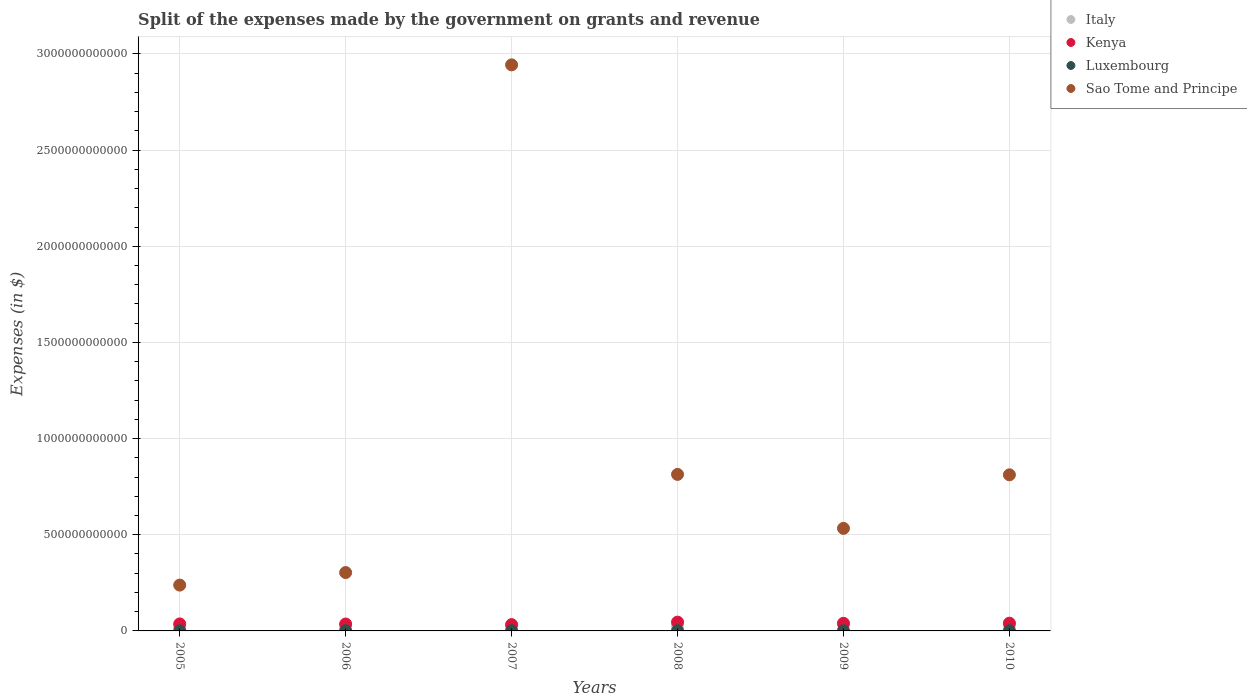How many different coloured dotlines are there?
Provide a succinct answer. 4. Is the number of dotlines equal to the number of legend labels?
Offer a terse response. Yes. What is the expenses made by the government on grants and revenue in Luxembourg in 2005?
Offer a terse response. 7.36e+08. Across all years, what is the maximum expenses made by the government on grants and revenue in Sao Tome and Principe?
Offer a very short reply. 2.94e+12. Across all years, what is the minimum expenses made by the government on grants and revenue in Luxembourg?
Your answer should be compact. 7.36e+08. In which year was the expenses made by the government on grants and revenue in Luxembourg maximum?
Offer a very short reply. 2008. In which year was the expenses made by the government on grants and revenue in Luxembourg minimum?
Make the answer very short. 2005. What is the total expenses made by the government on grants and revenue in Kenya in the graph?
Your response must be concise. 2.31e+11. What is the difference between the expenses made by the government on grants and revenue in Kenya in 2006 and that in 2008?
Give a very brief answer. -9.88e+09. What is the difference between the expenses made by the government on grants and revenue in Luxembourg in 2006 and the expenses made by the government on grants and revenue in Kenya in 2005?
Offer a terse response. -3.55e+1. What is the average expenses made by the government on grants and revenue in Kenya per year?
Give a very brief answer. 3.85e+1. In the year 2010, what is the difference between the expenses made by the government on grants and revenue in Kenya and expenses made by the government on grants and revenue in Luxembourg?
Offer a very short reply. 3.91e+1. What is the ratio of the expenses made by the government on grants and revenue in Italy in 2005 to that in 2010?
Keep it short and to the point. 0.76. Is the expenses made by the government on grants and revenue in Italy in 2006 less than that in 2010?
Provide a short and direct response. Yes. Is the difference between the expenses made by the government on grants and revenue in Kenya in 2006 and 2008 greater than the difference between the expenses made by the government on grants and revenue in Luxembourg in 2006 and 2008?
Your response must be concise. No. What is the difference between the highest and the second highest expenses made by the government on grants and revenue in Kenya?
Your answer should be very brief. 5.50e+09. What is the difference between the highest and the lowest expenses made by the government on grants and revenue in Kenya?
Your answer should be compact. 1.30e+1. In how many years, is the expenses made by the government on grants and revenue in Sao Tome and Principe greater than the average expenses made by the government on grants and revenue in Sao Tome and Principe taken over all years?
Your answer should be compact. 1. Is the expenses made by the government on grants and revenue in Sao Tome and Principe strictly greater than the expenses made by the government on grants and revenue in Kenya over the years?
Provide a short and direct response. Yes. Is the expenses made by the government on grants and revenue in Sao Tome and Principe strictly less than the expenses made by the government on grants and revenue in Italy over the years?
Make the answer very short. No. How many years are there in the graph?
Give a very brief answer. 6. What is the difference between two consecutive major ticks on the Y-axis?
Offer a terse response. 5.00e+11. Are the values on the major ticks of Y-axis written in scientific E-notation?
Provide a short and direct response. No. Does the graph contain any zero values?
Your answer should be very brief. No. How are the legend labels stacked?
Your answer should be very brief. Vertical. What is the title of the graph?
Make the answer very short. Split of the expenses made by the government on grants and revenue. Does "Brunei Darussalam" appear as one of the legend labels in the graph?
Your answer should be compact. No. What is the label or title of the X-axis?
Your response must be concise. Years. What is the label or title of the Y-axis?
Give a very brief answer. Expenses (in $). What is the Expenses (in $) of Italy in 2005?
Offer a very short reply. 2.16e+1. What is the Expenses (in $) of Kenya in 2005?
Keep it short and to the point. 3.64e+1. What is the Expenses (in $) of Luxembourg in 2005?
Provide a short and direct response. 7.36e+08. What is the Expenses (in $) in Sao Tome and Principe in 2005?
Ensure brevity in your answer.  2.38e+11. What is the Expenses (in $) in Italy in 2006?
Make the answer very short. 2.53e+1. What is the Expenses (in $) of Kenya in 2006?
Give a very brief answer. 3.59e+1. What is the Expenses (in $) in Luxembourg in 2006?
Make the answer very short. 9.05e+08. What is the Expenses (in $) of Sao Tome and Principe in 2006?
Provide a short and direct response. 3.04e+11. What is the Expenses (in $) of Italy in 2007?
Provide a succinct answer. 2.34e+1. What is the Expenses (in $) of Kenya in 2007?
Offer a terse response. 3.28e+1. What is the Expenses (in $) of Luxembourg in 2007?
Provide a succinct answer. 1.03e+09. What is the Expenses (in $) in Sao Tome and Principe in 2007?
Make the answer very short. 2.94e+12. What is the Expenses (in $) in Italy in 2008?
Your response must be concise. 2.44e+1. What is the Expenses (in $) of Kenya in 2008?
Provide a succinct answer. 4.58e+1. What is the Expenses (in $) in Luxembourg in 2008?
Provide a short and direct response. 1.19e+09. What is the Expenses (in $) of Sao Tome and Principe in 2008?
Provide a succinct answer. 8.14e+11. What is the Expenses (in $) in Italy in 2009?
Provide a succinct answer. 3.13e+1. What is the Expenses (in $) of Kenya in 2009?
Offer a terse response. 3.98e+1. What is the Expenses (in $) of Luxembourg in 2009?
Your answer should be very brief. 1.07e+09. What is the Expenses (in $) of Sao Tome and Principe in 2009?
Ensure brevity in your answer.  5.33e+11. What is the Expenses (in $) in Italy in 2010?
Your answer should be very brief. 2.84e+1. What is the Expenses (in $) of Kenya in 2010?
Provide a short and direct response. 4.03e+1. What is the Expenses (in $) of Luxembourg in 2010?
Offer a terse response. 1.15e+09. What is the Expenses (in $) in Sao Tome and Principe in 2010?
Your response must be concise. 8.12e+11. Across all years, what is the maximum Expenses (in $) in Italy?
Provide a succinct answer. 3.13e+1. Across all years, what is the maximum Expenses (in $) in Kenya?
Ensure brevity in your answer.  4.58e+1. Across all years, what is the maximum Expenses (in $) in Luxembourg?
Give a very brief answer. 1.19e+09. Across all years, what is the maximum Expenses (in $) of Sao Tome and Principe?
Make the answer very short. 2.94e+12. Across all years, what is the minimum Expenses (in $) of Italy?
Provide a short and direct response. 2.16e+1. Across all years, what is the minimum Expenses (in $) of Kenya?
Your answer should be very brief. 3.28e+1. Across all years, what is the minimum Expenses (in $) in Luxembourg?
Your response must be concise. 7.36e+08. Across all years, what is the minimum Expenses (in $) in Sao Tome and Principe?
Ensure brevity in your answer.  2.38e+11. What is the total Expenses (in $) in Italy in the graph?
Ensure brevity in your answer.  1.54e+11. What is the total Expenses (in $) in Kenya in the graph?
Your response must be concise. 2.31e+11. What is the total Expenses (in $) in Luxembourg in the graph?
Your answer should be very brief. 6.08e+09. What is the total Expenses (in $) of Sao Tome and Principe in the graph?
Offer a terse response. 5.64e+12. What is the difference between the Expenses (in $) in Italy in 2005 and that in 2006?
Your answer should be compact. -3.68e+09. What is the difference between the Expenses (in $) of Kenya in 2005 and that in 2006?
Provide a short and direct response. 5.04e+08. What is the difference between the Expenses (in $) in Luxembourg in 2005 and that in 2006?
Provide a succinct answer. -1.69e+08. What is the difference between the Expenses (in $) in Sao Tome and Principe in 2005 and that in 2006?
Your answer should be compact. -6.52e+1. What is the difference between the Expenses (in $) of Italy in 2005 and that in 2007?
Offer a very short reply. -1.71e+09. What is the difference between the Expenses (in $) of Kenya in 2005 and that in 2007?
Provide a short and direct response. 3.58e+09. What is the difference between the Expenses (in $) of Luxembourg in 2005 and that in 2007?
Your response must be concise. -2.95e+08. What is the difference between the Expenses (in $) of Sao Tome and Principe in 2005 and that in 2007?
Ensure brevity in your answer.  -2.71e+12. What is the difference between the Expenses (in $) in Italy in 2005 and that in 2008?
Give a very brief answer. -2.72e+09. What is the difference between the Expenses (in $) of Kenya in 2005 and that in 2008?
Your answer should be very brief. -9.38e+09. What is the difference between the Expenses (in $) of Luxembourg in 2005 and that in 2008?
Make the answer very short. -4.51e+08. What is the difference between the Expenses (in $) in Sao Tome and Principe in 2005 and that in 2008?
Give a very brief answer. -5.76e+11. What is the difference between the Expenses (in $) of Italy in 2005 and that in 2009?
Give a very brief answer. -9.61e+09. What is the difference between the Expenses (in $) in Kenya in 2005 and that in 2009?
Provide a short and direct response. -3.35e+09. What is the difference between the Expenses (in $) of Luxembourg in 2005 and that in 2009?
Ensure brevity in your answer.  -3.34e+08. What is the difference between the Expenses (in $) of Sao Tome and Principe in 2005 and that in 2009?
Give a very brief answer. -2.95e+11. What is the difference between the Expenses (in $) in Italy in 2005 and that in 2010?
Make the answer very short. -6.76e+09. What is the difference between the Expenses (in $) of Kenya in 2005 and that in 2010?
Your response must be concise. -3.87e+09. What is the difference between the Expenses (in $) in Luxembourg in 2005 and that in 2010?
Keep it short and to the point. -4.15e+08. What is the difference between the Expenses (in $) in Sao Tome and Principe in 2005 and that in 2010?
Your answer should be compact. -5.73e+11. What is the difference between the Expenses (in $) in Italy in 2006 and that in 2007?
Your answer should be compact. 1.98e+09. What is the difference between the Expenses (in $) in Kenya in 2006 and that in 2007?
Your response must be concise. 3.07e+09. What is the difference between the Expenses (in $) in Luxembourg in 2006 and that in 2007?
Provide a succinct answer. -1.26e+08. What is the difference between the Expenses (in $) of Sao Tome and Principe in 2006 and that in 2007?
Ensure brevity in your answer.  -2.64e+12. What is the difference between the Expenses (in $) of Italy in 2006 and that in 2008?
Offer a terse response. 9.65e+08. What is the difference between the Expenses (in $) in Kenya in 2006 and that in 2008?
Provide a succinct answer. -9.88e+09. What is the difference between the Expenses (in $) of Luxembourg in 2006 and that in 2008?
Ensure brevity in your answer.  -2.82e+08. What is the difference between the Expenses (in $) of Sao Tome and Principe in 2006 and that in 2008?
Offer a terse response. -5.10e+11. What is the difference between the Expenses (in $) of Italy in 2006 and that in 2009?
Give a very brief answer. -5.92e+09. What is the difference between the Expenses (in $) of Kenya in 2006 and that in 2009?
Offer a very short reply. -3.86e+09. What is the difference between the Expenses (in $) of Luxembourg in 2006 and that in 2009?
Keep it short and to the point. -1.65e+08. What is the difference between the Expenses (in $) in Sao Tome and Principe in 2006 and that in 2009?
Keep it short and to the point. -2.30e+11. What is the difference between the Expenses (in $) in Italy in 2006 and that in 2010?
Offer a very short reply. -3.08e+09. What is the difference between the Expenses (in $) of Kenya in 2006 and that in 2010?
Give a very brief answer. -4.38e+09. What is the difference between the Expenses (in $) of Luxembourg in 2006 and that in 2010?
Your response must be concise. -2.45e+08. What is the difference between the Expenses (in $) of Sao Tome and Principe in 2006 and that in 2010?
Your answer should be very brief. -5.08e+11. What is the difference between the Expenses (in $) of Italy in 2007 and that in 2008?
Ensure brevity in your answer.  -1.01e+09. What is the difference between the Expenses (in $) of Kenya in 2007 and that in 2008?
Offer a very short reply. -1.30e+1. What is the difference between the Expenses (in $) in Luxembourg in 2007 and that in 2008?
Ensure brevity in your answer.  -1.56e+08. What is the difference between the Expenses (in $) in Sao Tome and Principe in 2007 and that in 2008?
Keep it short and to the point. 2.13e+12. What is the difference between the Expenses (in $) of Italy in 2007 and that in 2009?
Your answer should be compact. -7.90e+09. What is the difference between the Expenses (in $) in Kenya in 2007 and that in 2009?
Keep it short and to the point. -6.93e+09. What is the difference between the Expenses (in $) in Luxembourg in 2007 and that in 2009?
Offer a very short reply. -3.93e+07. What is the difference between the Expenses (in $) of Sao Tome and Principe in 2007 and that in 2009?
Keep it short and to the point. 2.41e+12. What is the difference between the Expenses (in $) in Italy in 2007 and that in 2010?
Provide a short and direct response. -5.05e+09. What is the difference between the Expenses (in $) in Kenya in 2007 and that in 2010?
Give a very brief answer. -7.45e+09. What is the difference between the Expenses (in $) of Luxembourg in 2007 and that in 2010?
Offer a terse response. -1.19e+08. What is the difference between the Expenses (in $) of Sao Tome and Principe in 2007 and that in 2010?
Your response must be concise. 2.13e+12. What is the difference between the Expenses (in $) in Italy in 2008 and that in 2009?
Offer a terse response. -6.89e+09. What is the difference between the Expenses (in $) in Kenya in 2008 and that in 2009?
Your answer should be very brief. 6.02e+09. What is the difference between the Expenses (in $) of Luxembourg in 2008 and that in 2009?
Make the answer very short. 1.17e+08. What is the difference between the Expenses (in $) in Sao Tome and Principe in 2008 and that in 2009?
Your answer should be compact. 2.81e+11. What is the difference between the Expenses (in $) in Italy in 2008 and that in 2010?
Provide a short and direct response. -4.04e+09. What is the difference between the Expenses (in $) in Kenya in 2008 and that in 2010?
Keep it short and to the point. 5.50e+09. What is the difference between the Expenses (in $) in Luxembourg in 2008 and that in 2010?
Your answer should be very brief. 3.67e+07. What is the difference between the Expenses (in $) of Sao Tome and Principe in 2008 and that in 2010?
Keep it short and to the point. 2.14e+09. What is the difference between the Expenses (in $) in Italy in 2009 and that in 2010?
Ensure brevity in your answer.  2.85e+09. What is the difference between the Expenses (in $) in Kenya in 2009 and that in 2010?
Your answer should be very brief. -5.18e+08. What is the difference between the Expenses (in $) in Luxembourg in 2009 and that in 2010?
Make the answer very short. -8.02e+07. What is the difference between the Expenses (in $) of Sao Tome and Principe in 2009 and that in 2010?
Offer a terse response. -2.78e+11. What is the difference between the Expenses (in $) in Italy in 2005 and the Expenses (in $) in Kenya in 2006?
Your answer should be compact. -1.43e+1. What is the difference between the Expenses (in $) of Italy in 2005 and the Expenses (in $) of Luxembourg in 2006?
Offer a terse response. 2.07e+1. What is the difference between the Expenses (in $) of Italy in 2005 and the Expenses (in $) of Sao Tome and Principe in 2006?
Provide a succinct answer. -2.82e+11. What is the difference between the Expenses (in $) of Kenya in 2005 and the Expenses (in $) of Luxembourg in 2006?
Your answer should be very brief. 3.55e+1. What is the difference between the Expenses (in $) of Kenya in 2005 and the Expenses (in $) of Sao Tome and Principe in 2006?
Your response must be concise. -2.67e+11. What is the difference between the Expenses (in $) of Luxembourg in 2005 and the Expenses (in $) of Sao Tome and Principe in 2006?
Provide a succinct answer. -3.03e+11. What is the difference between the Expenses (in $) of Italy in 2005 and the Expenses (in $) of Kenya in 2007?
Make the answer very short. -1.12e+1. What is the difference between the Expenses (in $) of Italy in 2005 and the Expenses (in $) of Luxembourg in 2007?
Ensure brevity in your answer.  2.06e+1. What is the difference between the Expenses (in $) in Italy in 2005 and the Expenses (in $) in Sao Tome and Principe in 2007?
Make the answer very short. -2.92e+12. What is the difference between the Expenses (in $) in Kenya in 2005 and the Expenses (in $) in Luxembourg in 2007?
Your answer should be very brief. 3.54e+1. What is the difference between the Expenses (in $) in Kenya in 2005 and the Expenses (in $) in Sao Tome and Principe in 2007?
Ensure brevity in your answer.  -2.91e+12. What is the difference between the Expenses (in $) of Luxembourg in 2005 and the Expenses (in $) of Sao Tome and Principe in 2007?
Provide a short and direct response. -2.94e+12. What is the difference between the Expenses (in $) in Italy in 2005 and the Expenses (in $) in Kenya in 2008?
Provide a succinct answer. -2.41e+1. What is the difference between the Expenses (in $) of Italy in 2005 and the Expenses (in $) of Luxembourg in 2008?
Provide a succinct answer. 2.05e+1. What is the difference between the Expenses (in $) in Italy in 2005 and the Expenses (in $) in Sao Tome and Principe in 2008?
Provide a short and direct response. -7.92e+11. What is the difference between the Expenses (in $) in Kenya in 2005 and the Expenses (in $) in Luxembourg in 2008?
Offer a terse response. 3.52e+1. What is the difference between the Expenses (in $) of Kenya in 2005 and the Expenses (in $) of Sao Tome and Principe in 2008?
Give a very brief answer. -7.77e+11. What is the difference between the Expenses (in $) in Luxembourg in 2005 and the Expenses (in $) in Sao Tome and Principe in 2008?
Offer a very short reply. -8.13e+11. What is the difference between the Expenses (in $) in Italy in 2005 and the Expenses (in $) in Kenya in 2009?
Provide a succinct answer. -1.81e+1. What is the difference between the Expenses (in $) of Italy in 2005 and the Expenses (in $) of Luxembourg in 2009?
Provide a short and direct response. 2.06e+1. What is the difference between the Expenses (in $) in Italy in 2005 and the Expenses (in $) in Sao Tome and Principe in 2009?
Your answer should be compact. -5.12e+11. What is the difference between the Expenses (in $) of Kenya in 2005 and the Expenses (in $) of Luxembourg in 2009?
Your response must be concise. 3.53e+1. What is the difference between the Expenses (in $) of Kenya in 2005 and the Expenses (in $) of Sao Tome and Principe in 2009?
Provide a succinct answer. -4.97e+11. What is the difference between the Expenses (in $) of Luxembourg in 2005 and the Expenses (in $) of Sao Tome and Principe in 2009?
Offer a terse response. -5.33e+11. What is the difference between the Expenses (in $) in Italy in 2005 and the Expenses (in $) in Kenya in 2010?
Offer a terse response. -1.86e+1. What is the difference between the Expenses (in $) in Italy in 2005 and the Expenses (in $) in Luxembourg in 2010?
Your answer should be very brief. 2.05e+1. What is the difference between the Expenses (in $) in Italy in 2005 and the Expenses (in $) in Sao Tome and Principe in 2010?
Offer a very short reply. -7.90e+11. What is the difference between the Expenses (in $) in Kenya in 2005 and the Expenses (in $) in Luxembourg in 2010?
Your response must be concise. 3.53e+1. What is the difference between the Expenses (in $) in Kenya in 2005 and the Expenses (in $) in Sao Tome and Principe in 2010?
Offer a terse response. -7.75e+11. What is the difference between the Expenses (in $) of Luxembourg in 2005 and the Expenses (in $) of Sao Tome and Principe in 2010?
Make the answer very short. -8.11e+11. What is the difference between the Expenses (in $) of Italy in 2006 and the Expenses (in $) of Kenya in 2007?
Offer a very short reply. -7.51e+09. What is the difference between the Expenses (in $) in Italy in 2006 and the Expenses (in $) in Luxembourg in 2007?
Provide a succinct answer. 2.43e+1. What is the difference between the Expenses (in $) in Italy in 2006 and the Expenses (in $) in Sao Tome and Principe in 2007?
Your answer should be very brief. -2.92e+12. What is the difference between the Expenses (in $) in Kenya in 2006 and the Expenses (in $) in Luxembourg in 2007?
Your response must be concise. 3.49e+1. What is the difference between the Expenses (in $) of Kenya in 2006 and the Expenses (in $) of Sao Tome and Principe in 2007?
Make the answer very short. -2.91e+12. What is the difference between the Expenses (in $) of Luxembourg in 2006 and the Expenses (in $) of Sao Tome and Principe in 2007?
Offer a terse response. -2.94e+12. What is the difference between the Expenses (in $) in Italy in 2006 and the Expenses (in $) in Kenya in 2008?
Your answer should be very brief. -2.05e+1. What is the difference between the Expenses (in $) of Italy in 2006 and the Expenses (in $) of Luxembourg in 2008?
Ensure brevity in your answer.  2.41e+1. What is the difference between the Expenses (in $) of Italy in 2006 and the Expenses (in $) of Sao Tome and Principe in 2008?
Your response must be concise. -7.89e+11. What is the difference between the Expenses (in $) in Kenya in 2006 and the Expenses (in $) in Luxembourg in 2008?
Offer a terse response. 3.47e+1. What is the difference between the Expenses (in $) of Kenya in 2006 and the Expenses (in $) of Sao Tome and Principe in 2008?
Your response must be concise. -7.78e+11. What is the difference between the Expenses (in $) in Luxembourg in 2006 and the Expenses (in $) in Sao Tome and Principe in 2008?
Your answer should be compact. -8.13e+11. What is the difference between the Expenses (in $) in Italy in 2006 and the Expenses (in $) in Kenya in 2009?
Provide a succinct answer. -1.44e+1. What is the difference between the Expenses (in $) in Italy in 2006 and the Expenses (in $) in Luxembourg in 2009?
Ensure brevity in your answer.  2.43e+1. What is the difference between the Expenses (in $) in Italy in 2006 and the Expenses (in $) in Sao Tome and Principe in 2009?
Offer a very short reply. -5.08e+11. What is the difference between the Expenses (in $) in Kenya in 2006 and the Expenses (in $) in Luxembourg in 2009?
Provide a short and direct response. 3.48e+1. What is the difference between the Expenses (in $) of Kenya in 2006 and the Expenses (in $) of Sao Tome and Principe in 2009?
Ensure brevity in your answer.  -4.97e+11. What is the difference between the Expenses (in $) of Luxembourg in 2006 and the Expenses (in $) of Sao Tome and Principe in 2009?
Provide a succinct answer. -5.32e+11. What is the difference between the Expenses (in $) of Italy in 2006 and the Expenses (in $) of Kenya in 2010?
Provide a short and direct response. -1.50e+1. What is the difference between the Expenses (in $) in Italy in 2006 and the Expenses (in $) in Luxembourg in 2010?
Offer a terse response. 2.42e+1. What is the difference between the Expenses (in $) in Italy in 2006 and the Expenses (in $) in Sao Tome and Principe in 2010?
Offer a terse response. -7.86e+11. What is the difference between the Expenses (in $) in Kenya in 2006 and the Expenses (in $) in Luxembourg in 2010?
Provide a succinct answer. 3.48e+1. What is the difference between the Expenses (in $) of Kenya in 2006 and the Expenses (in $) of Sao Tome and Principe in 2010?
Provide a succinct answer. -7.76e+11. What is the difference between the Expenses (in $) in Luxembourg in 2006 and the Expenses (in $) in Sao Tome and Principe in 2010?
Your answer should be compact. -8.11e+11. What is the difference between the Expenses (in $) of Italy in 2007 and the Expenses (in $) of Kenya in 2008?
Provide a short and direct response. -2.24e+1. What is the difference between the Expenses (in $) in Italy in 2007 and the Expenses (in $) in Luxembourg in 2008?
Keep it short and to the point. 2.22e+1. What is the difference between the Expenses (in $) of Italy in 2007 and the Expenses (in $) of Sao Tome and Principe in 2008?
Offer a very short reply. -7.91e+11. What is the difference between the Expenses (in $) in Kenya in 2007 and the Expenses (in $) in Luxembourg in 2008?
Your answer should be very brief. 3.17e+1. What is the difference between the Expenses (in $) in Kenya in 2007 and the Expenses (in $) in Sao Tome and Principe in 2008?
Give a very brief answer. -7.81e+11. What is the difference between the Expenses (in $) in Luxembourg in 2007 and the Expenses (in $) in Sao Tome and Principe in 2008?
Provide a succinct answer. -8.13e+11. What is the difference between the Expenses (in $) of Italy in 2007 and the Expenses (in $) of Kenya in 2009?
Keep it short and to the point. -1.64e+1. What is the difference between the Expenses (in $) in Italy in 2007 and the Expenses (in $) in Luxembourg in 2009?
Your answer should be very brief. 2.23e+1. What is the difference between the Expenses (in $) of Italy in 2007 and the Expenses (in $) of Sao Tome and Principe in 2009?
Your response must be concise. -5.10e+11. What is the difference between the Expenses (in $) in Kenya in 2007 and the Expenses (in $) in Luxembourg in 2009?
Give a very brief answer. 3.18e+1. What is the difference between the Expenses (in $) in Kenya in 2007 and the Expenses (in $) in Sao Tome and Principe in 2009?
Offer a very short reply. -5.00e+11. What is the difference between the Expenses (in $) in Luxembourg in 2007 and the Expenses (in $) in Sao Tome and Principe in 2009?
Your answer should be very brief. -5.32e+11. What is the difference between the Expenses (in $) in Italy in 2007 and the Expenses (in $) in Kenya in 2010?
Make the answer very short. -1.69e+1. What is the difference between the Expenses (in $) of Italy in 2007 and the Expenses (in $) of Luxembourg in 2010?
Your response must be concise. 2.22e+1. What is the difference between the Expenses (in $) of Italy in 2007 and the Expenses (in $) of Sao Tome and Principe in 2010?
Your answer should be very brief. -7.88e+11. What is the difference between the Expenses (in $) in Kenya in 2007 and the Expenses (in $) in Luxembourg in 2010?
Make the answer very short. 3.17e+1. What is the difference between the Expenses (in $) in Kenya in 2007 and the Expenses (in $) in Sao Tome and Principe in 2010?
Your answer should be compact. -7.79e+11. What is the difference between the Expenses (in $) in Luxembourg in 2007 and the Expenses (in $) in Sao Tome and Principe in 2010?
Give a very brief answer. -8.11e+11. What is the difference between the Expenses (in $) in Italy in 2008 and the Expenses (in $) in Kenya in 2009?
Your answer should be compact. -1.54e+1. What is the difference between the Expenses (in $) of Italy in 2008 and the Expenses (in $) of Luxembourg in 2009?
Your answer should be compact. 2.33e+1. What is the difference between the Expenses (in $) of Italy in 2008 and the Expenses (in $) of Sao Tome and Principe in 2009?
Give a very brief answer. -5.09e+11. What is the difference between the Expenses (in $) of Kenya in 2008 and the Expenses (in $) of Luxembourg in 2009?
Provide a succinct answer. 4.47e+1. What is the difference between the Expenses (in $) in Kenya in 2008 and the Expenses (in $) in Sao Tome and Principe in 2009?
Make the answer very short. -4.87e+11. What is the difference between the Expenses (in $) of Luxembourg in 2008 and the Expenses (in $) of Sao Tome and Principe in 2009?
Your response must be concise. -5.32e+11. What is the difference between the Expenses (in $) in Italy in 2008 and the Expenses (in $) in Kenya in 2010?
Give a very brief answer. -1.59e+1. What is the difference between the Expenses (in $) of Italy in 2008 and the Expenses (in $) of Luxembourg in 2010?
Offer a terse response. 2.32e+1. What is the difference between the Expenses (in $) in Italy in 2008 and the Expenses (in $) in Sao Tome and Principe in 2010?
Offer a very short reply. -7.87e+11. What is the difference between the Expenses (in $) in Kenya in 2008 and the Expenses (in $) in Luxembourg in 2010?
Offer a very short reply. 4.46e+1. What is the difference between the Expenses (in $) of Kenya in 2008 and the Expenses (in $) of Sao Tome and Principe in 2010?
Your answer should be very brief. -7.66e+11. What is the difference between the Expenses (in $) in Luxembourg in 2008 and the Expenses (in $) in Sao Tome and Principe in 2010?
Make the answer very short. -8.11e+11. What is the difference between the Expenses (in $) of Italy in 2009 and the Expenses (in $) of Kenya in 2010?
Offer a terse response. -9.04e+09. What is the difference between the Expenses (in $) of Italy in 2009 and the Expenses (in $) of Luxembourg in 2010?
Give a very brief answer. 3.01e+1. What is the difference between the Expenses (in $) of Italy in 2009 and the Expenses (in $) of Sao Tome and Principe in 2010?
Make the answer very short. -7.81e+11. What is the difference between the Expenses (in $) of Kenya in 2009 and the Expenses (in $) of Luxembourg in 2010?
Keep it short and to the point. 3.86e+1. What is the difference between the Expenses (in $) of Kenya in 2009 and the Expenses (in $) of Sao Tome and Principe in 2010?
Give a very brief answer. -7.72e+11. What is the difference between the Expenses (in $) of Luxembourg in 2009 and the Expenses (in $) of Sao Tome and Principe in 2010?
Make the answer very short. -8.11e+11. What is the average Expenses (in $) in Italy per year?
Your answer should be compact. 2.57e+1. What is the average Expenses (in $) of Kenya per year?
Offer a terse response. 3.85e+1. What is the average Expenses (in $) in Luxembourg per year?
Offer a terse response. 1.01e+09. What is the average Expenses (in $) of Sao Tome and Principe per year?
Give a very brief answer. 9.41e+11. In the year 2005, what is the difference between the Expenses (in $) in Italy and Expenses (in $) in Kenya?
Offer a very short reply. -1.48e+1. In the year 2005, what is the difference between the Expenses (in $) of Italy and Expenses (in $) of Luxembourg?
Provide a succinct answer. 2.09e+1. In the year 2005, what is the difference between the Expenses (in $) in Italy and Expenses (in $) in Sao Tome and Principe?
Make the answer very short. -2.17e+11. In the year 2005, what is the difference between the Expenses (in $) in Kenya and Expenses (in $) in Luxembourg?
Your answer should be compact. 3.57e+1. In the year 2005, what is the difference between the Expenses (in $) in Kenya and Expenses (in $) in Sao Tome and Principe?
Make the answer very short. -2.02e+11. In the year 2005, what is the difference between the Expenses (in $) in Luxembourg and Expenses (in $) in Sao Tome and Principe?
Provide a succinct answer. -2.38e+11. In the year 2006, what is the difference between the Expenses (in $) of Italy and Expenses (in $) of Kenya?
Provide a short and direct response. -1.06e+1. In the year 2006, what is the difference between the Expenses (in $) of Italy and Expenses (in $) of Luxembourg?
Your answer should be compact. 2.44e+1. In the year 2006, what is the difference between the Expenses (in $) in Italy and Expenses (in $) in Sao Tome and Principe?
Your answer should be compact. -2.78e+11. In the year 2006, what is the difference between the Expenses (in $) of Kenya and Expenses (in $) of Luxembourg?
Offer a very short reply. 3.50e+1. In the year 2006, what is the difference between the Expenses (in $) in Kenya and Expenses (in $) in Sao Tome and Principe?
Offer a terse response. -2.68e+11. In the year 2006, what is the difference between the Expenses (in $) in Luxembourg and Expenses (in $) in Sao Tome and Principe?
Provide a succinct answer. -3.03e+11. In the year 2007, what is the difference between the Expenses (in $) in Italy and Expenses (in $) in Kenya?
Offer a very short reply. -9.49e+09. In the year 2007, what is the difference between the Expenses (in $) of Italy and Expenses (in $) of Luxembourg?
Provide a succinct answer. 2.23e+1. In the year 2007, what is the difference between the Expenses (in $) of Italy and Expenses (in $) of Sao Tome and Principe?
Offer a very short reply. -2.92e+12. In the year 2007, what is the difference between the Expenses (in $) in Kenya and Expenses (in $) in Luxembourg?
Ensure brevity in your answer.  3.18e+1. In the year 2007, what is the difference between the Expenses (in $) of Kenya and Expenses (in $) of Sao Tome and Principe?
Provide a succinct answer. -2.91e+12. In the year 2007, what is the difference between the Expenses (in $) of Luxembourg and Expenses (in $) of Sao Tome and Principe?
Your answer should be compact. -2.94e+12. In the year 2008, what is the difference between the Expenses (in $) of Italy and Expenses (in $) of Kenya?
Offer a very short reply. -2.14e+1. In the year 2008, what is the difference between the Expenses (in $) of Italy and Expenses (in $) of Luxembourg?
Your answer should be very brief. 2.32e+1. In the year 2008, what is the difference between the Expenses (in $) of Italy and Expenses (in $) of Sao Tome and Principe?
Your answer should be compact. -7.90e+11. In the year 2008, what is the difference between the Expenses (in $) of Kenya and Expenses (in $) of Luxembourg?
Provide a short and direct response. 4.46e+1. In the year 2008, what is the difference between the Expenses (in $) in Kenya and Expenses (in $) in Sao Tome and Principe?
Offer a very short reply. -7.68e+11. In the year 2008, what is the difference between the Expenses (in $) of Luxembourg and Expenses (in $) of Sao Tome and Principe?
Offer a terse response. -8.13e+11. In the year 2009, what is the difference between the Expenses (in $) of Italy and Expenses (in $) of Kenya?
Provide a succinct answer. -8.52e+09. In the year 2009, what is the difference between the Expenses (in $) of Italy and Expenses (in $) of Luxembourg?
Make the answer very short. 3.02e+1. In the year 2009, what is the difference between the Expenses (in $) in Italy and Expenses (in $) in Sao Tome and Principe?
Provide a succinct answer. -5.02e+11. In the year 2009, what is the difference between the Expenses (in $) of Kenya and Expenses (in $) of Luxembourg?
Provide a short and direct response. 3.87e+1. In the year 2009, what is the difference between the Expenses (in $) of Kenya and Expenses (in $) of Sao Tome and Principe?
Your answer should be very brief. -4.94e+11. In the year 2009, what is the difference between the Expenses (in $) in Luxembourg and Expenses (in $) in Sao Tome and Principe?
Your answer should be compact. -5.32e+11. In the year 2010, what is the difference between the Expenses (in $) of Italy and Expenses (in $) of Kenya?
Offer a terse response. -1.19e+1. In the year 2010, what is the difference between the Expenses (in $) in Italy and Expenses (in $) in Luxembourg?
Provide a short and direct response. 2.73e+1. In the year 2010, what is the difference between the Expenses (in $) of Italy and Expenses (in $) of Sao Tome and Principe?
Your answer should be very brief. -7.83e+11. In the year 2010, what is the difference between the Expenses (in $) of Kenya and Expenses (in $) of Luxembourg?
Offer a very short reply. 3.91e+1. In the year 2010, what is the difference between the Expenses (in $) of Kenya and Expenses (in $) of Sao Tome and Principe?
Provide a succinct answer. -7.71e+11. In the year 2010, what is the difference between the Expenses (in $) of Luxembourg and Expenses (in $) of Sao Tome and Principe?
Your response must be concise. -8.11e+11. What is the ratio of the Expenses (in $) in Italy in 2005 to that in 2006?
Give a very brief answer. 0.85. What is the ratio of the Expenses (in $) in Kenya in 2005 to that in 2006?
Provide a succinct answer. 1.01. What is the ratio of the Expenses (in $) in Luxembourg in 2005 to that in 2006?
Provide a short and direct response. 0.81. What is the ratio of the Expenses (in $) in Sao Tome and Principe in 2005 to that in 2006?
Ensure brevity in your answer.  0.79. What is the ratio of the Expenses (in $) in Italy in 2005 to that in 2007?
Offer a terse response. 0.93. What is the ratio of the Expenses (in $) of Kenya in 2005 to that in 2007?
Ensure brevity in your answer.  1.11. What is the ratio of the Expenses (in $) in Luxembourg in 2005 to that in 2007?
Offer a terse response. 0.71. What is the ratio of the Expenses (in $) of Sao Tome and Principe in 2005 to that in 2007?
Your answer should be compact. 0.08. What is the ratio of the Expenses (in $) of Italy in 2005 to that in 2008?
Ensure brevity in your answer.  0.89. What is the ratio of the Expenses (in $) in Kenya in 2005 to that in 2008?
Provide a short and direct response. 0.8. What is the ratio of the Expenses (in $) in Luxembourg in 2005 to that in 2008?
Offer a very short reply. 0.62. What is the ratio of the Expenses (in $) of Sao Tome and Principe in 2005 to that in 2008?
Make the answer very short. 0.29. What is the ratio of the Expenses (in $) in Italy in 2005 to that in 2009?
Ensure brevity in your answer.  0.69. What is the ratio of the Expenses (in $) in Kenya in 2005 to that in 2009?
Keep it short and to the point. 0.92. What is the ratio of the Expenses (in $) in Luxembourg in 2005 to that in 2009?
Ensure brevity in your answer.  0.69. What is the ratio of the Expenses (in $) of Sao Tome and Principe in 2005 to that in 2009?
Keep it short and to the point. 0.45. What is the ratio of the Expenses (in $) of Italy in 2005 to that in 2010?
Provide a short and direct response. 0.76. What is the ratio of the Expenses (in $) in Kenya in 2005 to that in 2010?
Provide a succinct answer. 0.9. What is the ratio of the Expenses (in $) in Luxembourg in 2005 to that in 2010?
Offer a terse response. 0.64. What is the ratio of the Expenses (in $) in Sao Tome and Principe in 2005 to that in 2010?
Keep it short and to the point. 0.29. What is the ratio of the Expenses (in $) in Italy in 2006 to that in 2007?
Offer a terse response. 1.08. What is the ratio of the Expenses (in $) of Kenya in 2006 to that in 2007?
Offer a very short reply. 1.09. What is the ratio of the Expenses (in $) in Luxembourg in 2006 to that in 2007?
Give a very brief answer. 0.88. What is the ratio of the Expenses (in $) in Sao Tome and Principe in 2006 to that in 2007?
Give a very brief answer. 0.1. What is the ratio of the Expenses (in $) in Italy in 2006 to that in 2008?
Provide a succinct answer. 1.04. What is the ratio of the Expenses (in $) in Kenya in 2006 to that in 2008?
Your response must be concise. 0.78. What is the ratio of the Expenses (in $) of Luxembourg in 2006 to that in 2008?
Offer a terse response. 0.76. What is the ratio of the Expenses (in $) of Sao Tome and Principe in 2006 to that in 2008?
Provide a succinct answer. 0.37. What is the ratio of the Expenses (in $) of Italy in 2006 to that in 2009?
Offer a very short reply. 0.81. What is the ratio of the Expenses (in $) in Kenya in 2006 to that in 2009?
Provide a succinct answer. 0.9. What is the ratio of the Expenses (in $) of Luxembourg in 2006 to that in 2009?
Make the answer very short. 0.85. What is the ratio of the Expenses (in $) of Sao Tome and Principe in 2006 to that in 2009?
Provide a short and direct response. 0.57. What is the ratio of the Expenses (in $) of Italy in 2006 to that in 2010?
Offer a terse response. 0.89. What is the ratio of the Expenses (in $) in Kenya in 2006 to that in 2010?
Your answer should be very brief. 0.89. What is the ratio of the Expenses (in $) in Luxembourg in 2006 to that in 2010?
Your response must be concise. 0.79. What is the ratio of the Expenses (in $) in Sao Tome and Principe in 2006 to that in 2010?
Your answer should be compact. 0.37. What is the ratio of the Expenses (in $) in Italy in 2007 to that in 2008?
Your response must be concise. 0.96. What is the ratio of the Expenses (in $) of Kenya in 2007 to that in 2008?
Offer a terse response. 0.72. What is the ratio of the Expenses (in $) in Luxembourg in 2007 to that in 2008?
Give a very brief answer. 0.87. What is the ratio of the Expenses (in $) in Sao Tome and Principe in 2007 to that in 2008?
Your response must be concise. 3.62. What is the ratio of the Expenses (in $) in Italy in 2007 to that in 2009?
Give a very brief answer. 0.75. What is the ratio of the Expenses (in $) of Kenya in 2007 to that in 2009?
Ensure brevity in your answer.  0.83. What is the ratio of the Expenses (in $) of Luxembourg in 2007 to that in 2009?
Ensure brevity in your answer.  0.96. What is the ratio of the Expenses (in $) of Sao Tome and Principe in 2007 to that in 2009?
Ensure brevity in your answer.  5.52. What is the ratio of the Expenses (in $) in Italy in 2007 to that in 2010?
Your answer should be compact. 0.82. What is the ratio of the Expenses (in $) of Kenya in 2007 to that in 2010?
Your answer should be compact. 0.82. What is the ratio of the Expenses (in $) in Luxembourg in 2007 to that in 2010?
Provide a short and direct response. 0.9. What is the ratio of the Expenses (in $) of Sao Tome and Principe in 2007 to that in 2010?
Your answer should be compact. 3.63. What is the ratio of the Expenses (in $) of Italy in 2008 to that in 2009?
Make the answer very short. 0.78. What is the ratio of the Expenses (in $) in Kenya in 2008 to that in 2009?
Keep it short and to the point. 1.15. What is the ratio of the Expenses (in $) in Luxembourg in 2008 to that in 2009?
Keep it short and to the point. 1.11. What is the ratio of the Expenses (in $) of Sao Tome and Principe in 2008 to that in 2009?
Your answer should be compact. 1.53. What is the ratio of the Expenses (in $) in Italy in 2008 to that in 2010?
Offer a very short reply. 0.86. What is the ratio of the Expenses (in $) of Kenya in 2008 to that in 2010?
Offer a terse response. 1.14. What is the ratio of the Expenses (in $) in Luxembourg in 2008 to that in 2010?
Provide a succinct answer. 1.03. What is the ratio of the Expenses (in $) of Sao Tome and Principe in 2008 to that in 2010?
Provide a succinct answer. 1. What is the ratio of the Expenses (in $) in Italy in 2009 to that in 2010?
Give a very brief answer. 1.1. What is the ratio of the Expenses (in $) in Kenya in 2009 to that in 2010?
Give a very brief answer. 0.99. What is the ratio of the Expenses (in $) in Luxembourg in 2009 to that in 2010?
Offer a terse response. 0.93. What is the ratio of the Expenses (in $) of Sao Tome and Principe in 2009 to that in 2010?
Keep it short and to the point. 0.66. What is the difference between the highest and the second highest Expenses (in $) in Italy?
Offer a very short reply. 2.85e+09. What is the difference between the highest and the second highest Expenses (in $) in Kenya?
Your answer should be compact. 5.50e+09. What is the difference between the highest and the second highest Expenses (in $) in Luxembourg?
Your answer should be compact. 3.67e+07. What is the difference between the highest and the second highest Expenses (in $) in Sao Tome and Principe?
Offer a terse response. 2.13e+12. What is the difference between the highest and the lowest Expenses (in $) in Italy?
Offer a terse response. 9.61e+09. What is the difference between the highest and the lowest Expenses (in $) of Kenya?
Ensure brevity in your answer.  1.30e+1. What is the difference between the highest and the lowest Expenses (in $) of Luxembourg?
Offer a very short reply. 4.51e+08. What is the difference between the highest and the lowest Expenses (in $) of Sao Tome and Principe?
Offer a very short reply. 2.71e+12. 